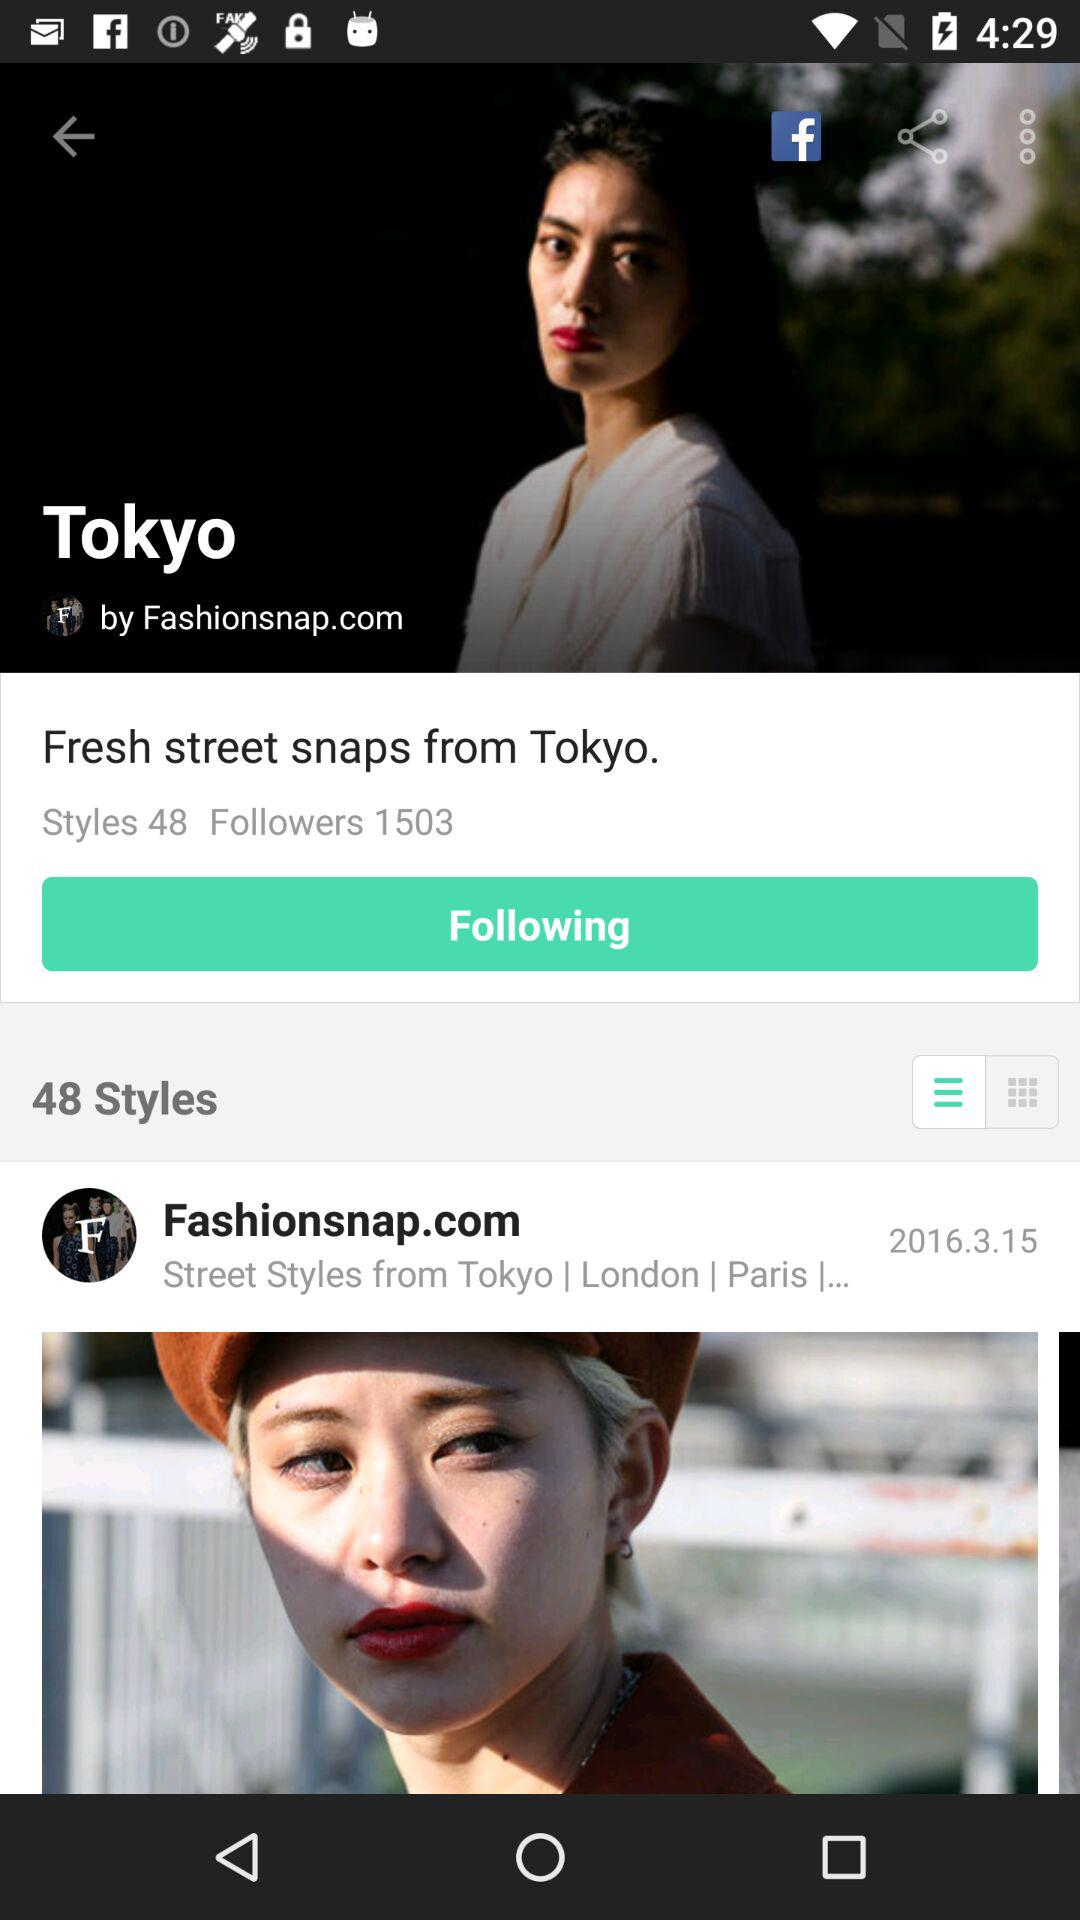How many styles are there? There are 48 styles. 